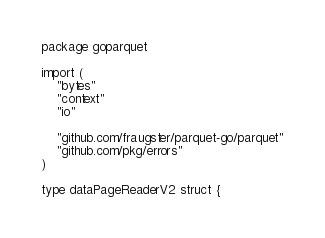<code> <loc_0><loc_0><loc_500><loc_500><_Go_>package goparquet

import (
	"bytes"
	"context"
	"io"

	"github.com/fraugster/parquet-go/parquet"
	"github.com/pkg/errors"
)

type dataPageReaderV2 struct {</code> 